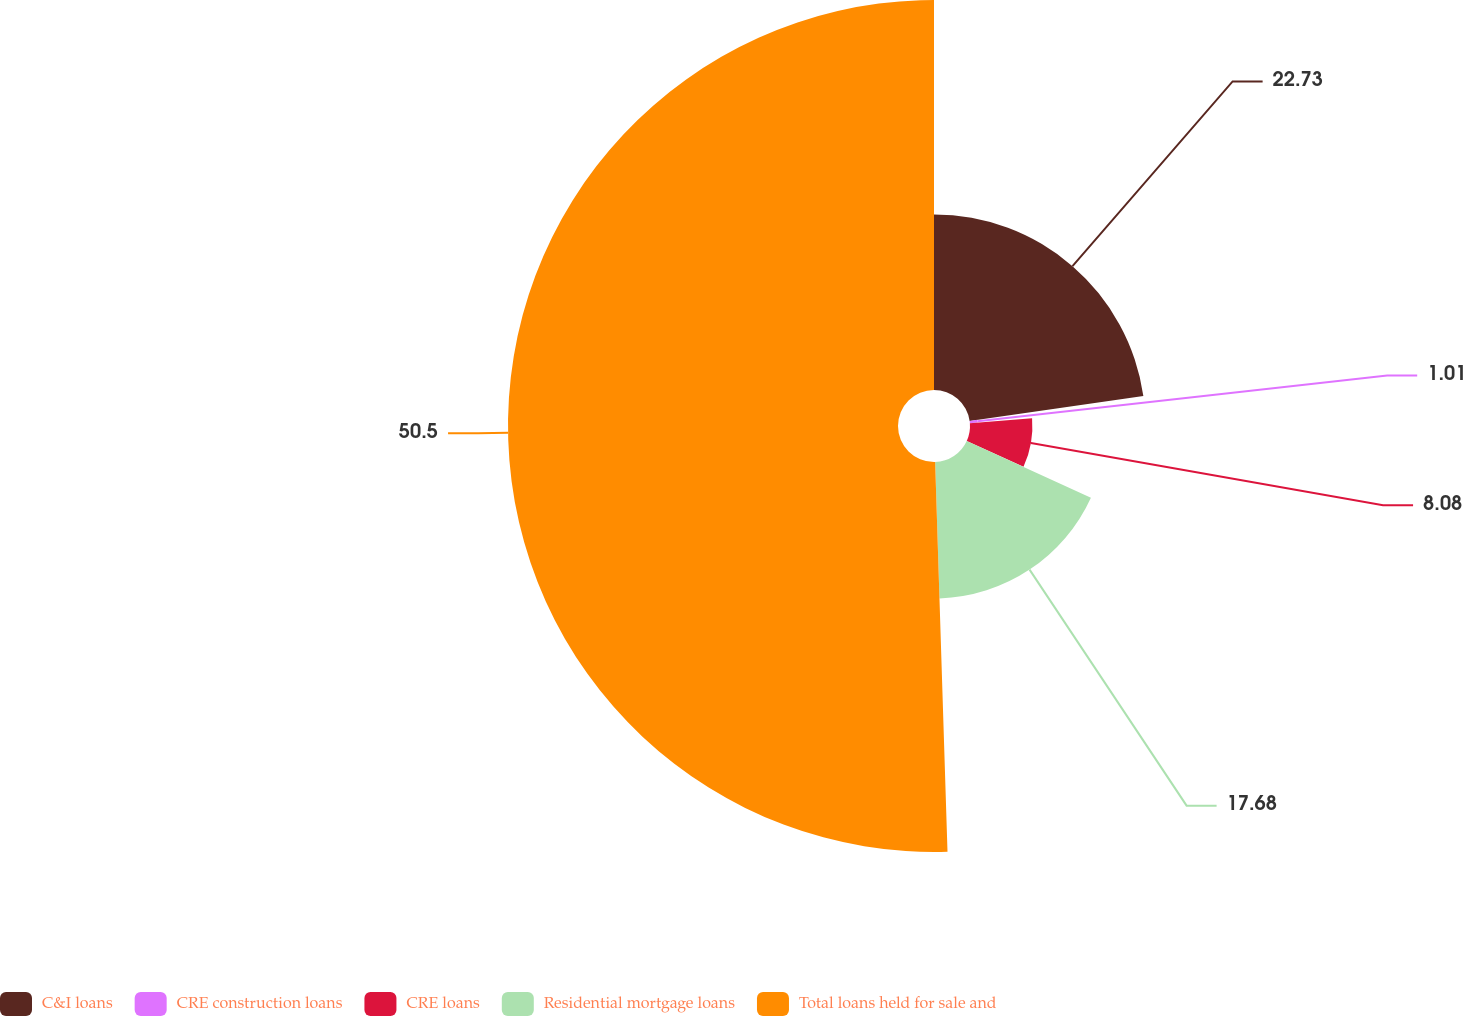<chart> <loc_0><loc_0><loc_500><loc_500><pie_chart><fcel>C&I loans<fcel>CRE construction loans<fcel>CRE loans<fcel>Residential mortgage loans<fcel>Total loans held for sale and<nl><fcel>22.73%<fcel>1.01%<fcel>8.08%<fcel>17.68%<fcel>50.51%<nl></chart> 